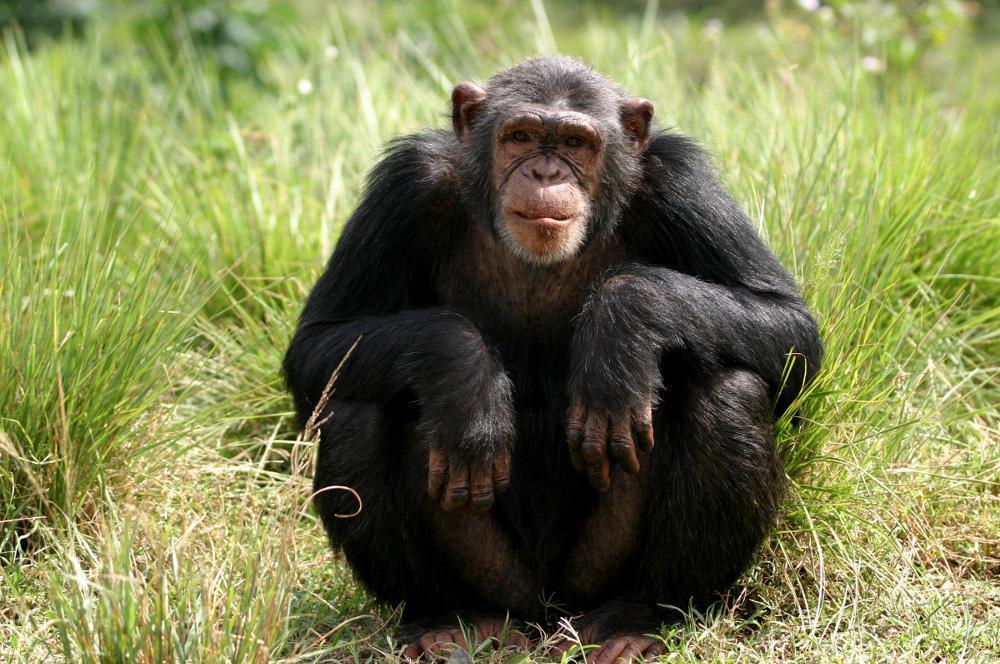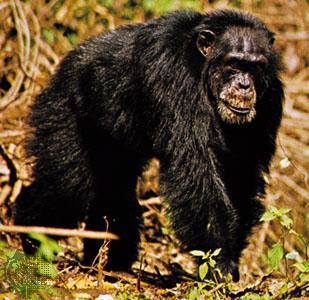The first image is the image on the left, the second image is the image on the right. Considering the images on both sides, is "There are at least two chimpanzees in each image." valid? Answer yes or no. No. The first image is the image on the left, the second image is the image on the right. Analyze the images presented: Is the assertion "There is more than one chimp in every single image." valid? Answer yes or no. No. 